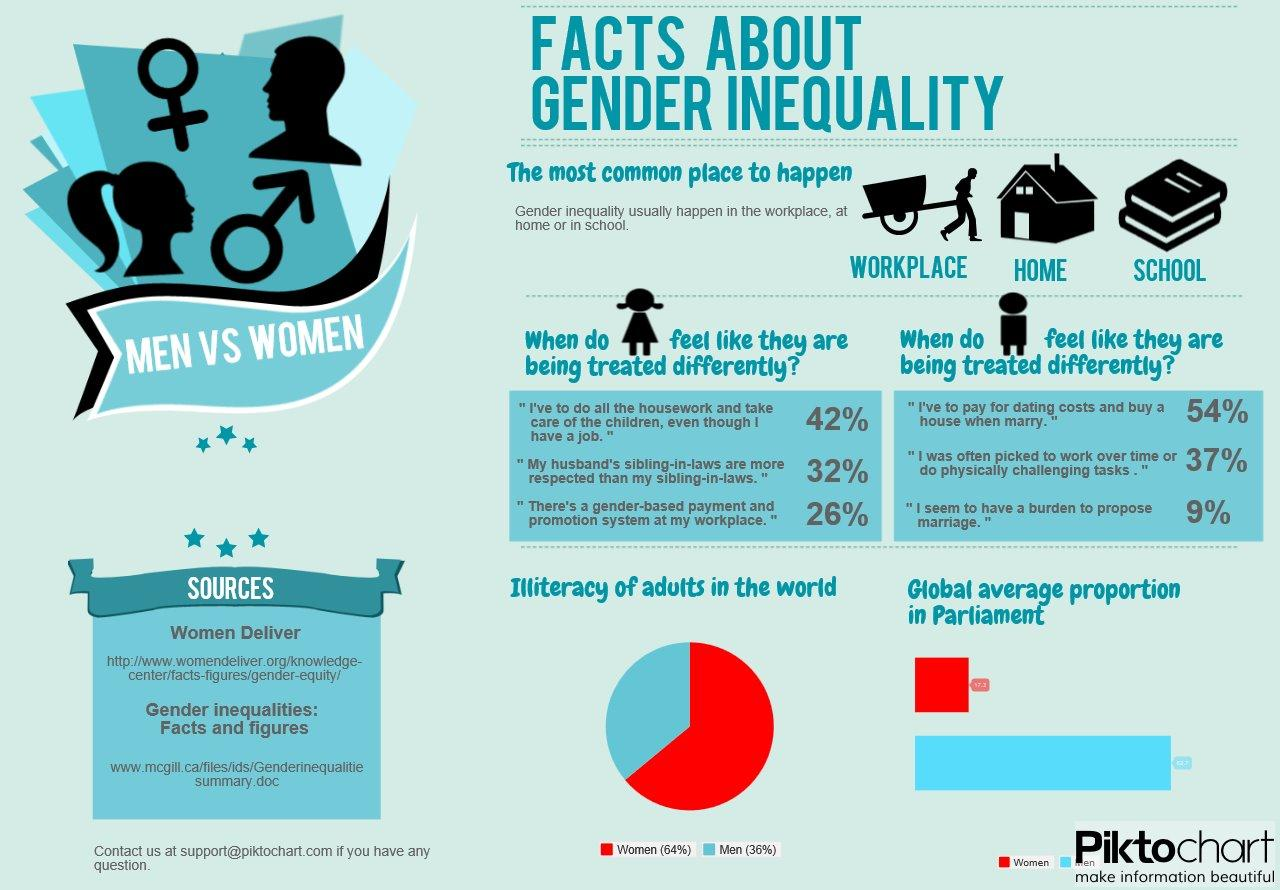Outline some significant characteristics in this image. According to recent data, approximately 35% of males worldwide are illiterate. The illiteracy rate among females globally is 64%. Nine percent of men seem to carry the burden of proposing marriage, while the remaining gender is not obligated to do so. In the global average, females are represented in parliament in either red or blue. 54% of men believe that they are responsible for paying for dating costs and buying a house when they get married. 